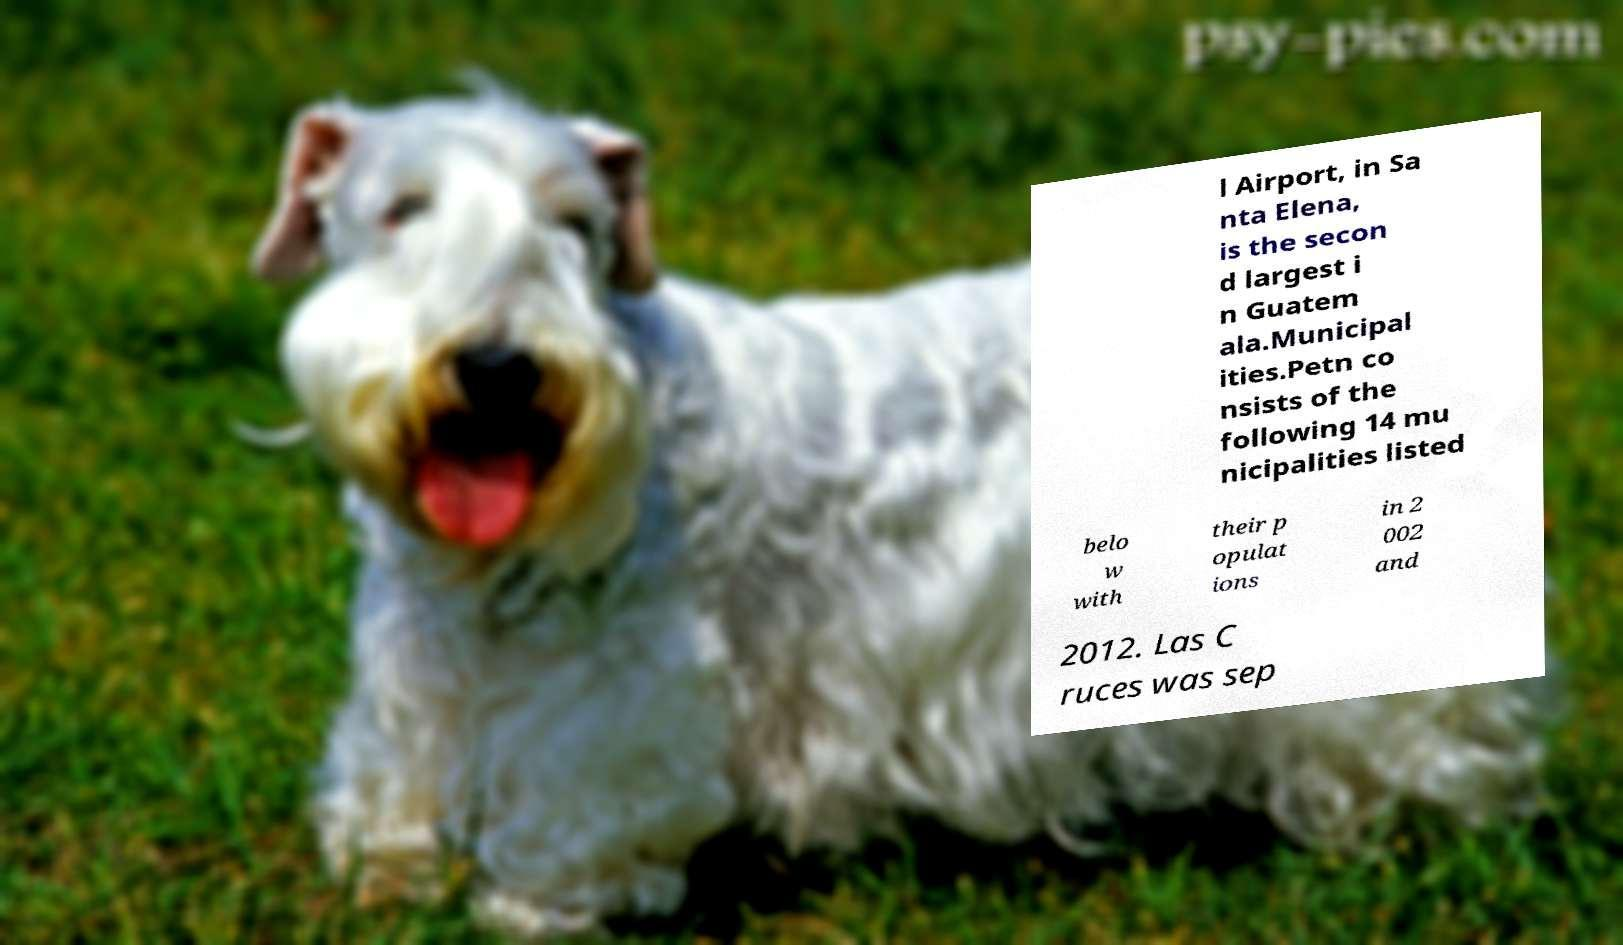Can you accurately transcribe the text from the provided image for me? l Airport, in Sa nta Elena, is the secon d largest i n Guatem ala.Municipal ities.Petn co nsists of the following 14 mu nicipalities listed belo w with their p opulat ions in 2 002 and 2012. Las C ruces was sep 